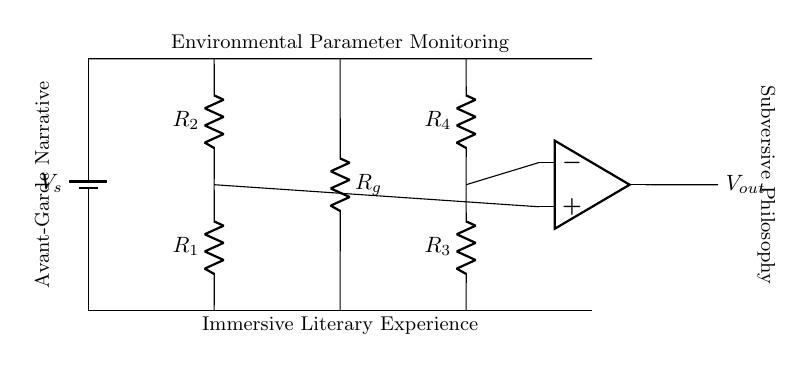What is the function of the voltage source in this circuit? The voltage source provides the necessary electrical energy for the circuit to operate, creating a potential difference that drives the current through the components.
Answer: Provides energy What are the values of the resistors in the left branch? The left branch contains resistors labeled R1 and R2, which are part of the Anderson loop bridge setup. The specific values are not provided in the diagram, but they assist in balancing the bridge.
Answer: R1 and R2 How many resistors are used in total in this circuit? There are four resistors in the circuit: R1, R2 in the left branch, and R3, R4 in the right branch, plus one additional resistor Rg in the middle branch.
Answer: Five resistors What type of circuit is represented by this configuration? This configuration represents an Anderson loop bridge circuit, which is typically used for precision measurement of small changes in resistance and environmental parameters.
Answer: Bridge circuit What is the purpose of the operational amplifier in this circuit? The operational amplifier amplifies the voltage difference between the two input nodes, allowing for enhanced measurement sensitivity of current fluctuations in the bridge circuit, which aids in monitoring environmental parameters.
Answer: Amplifies voltage difference Which branch contains the ground reference? The ground reference is represented by the resistor labeled Rg in the middle branch, which connects to the common reference point in the circuit.
Answer: Middle branch In the context of the narrative, what does the circuit symbolize? The circuit symbolizes the fusion of technology and literature, where environmental parameters monitor the immersive experiences of avant-garde narratives, reflecting on the interaction between philosophy and storytelling.
Answer: Fusion of technology and literature 